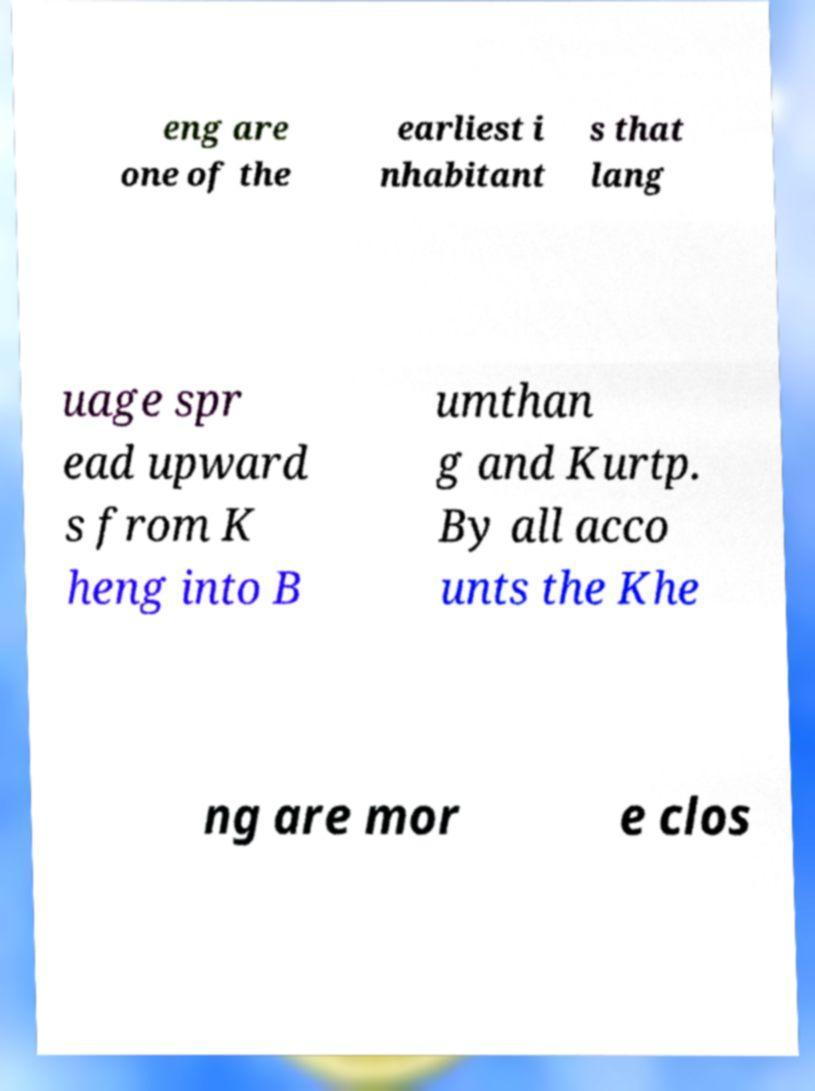Please identify and transcribe the text found in this image. eng are one of the earliest i nhabitant s that lang uage spr ead upward s from K heng into B umthan g and Kurtp. By all acco unts the Khe ng are mor e clos 